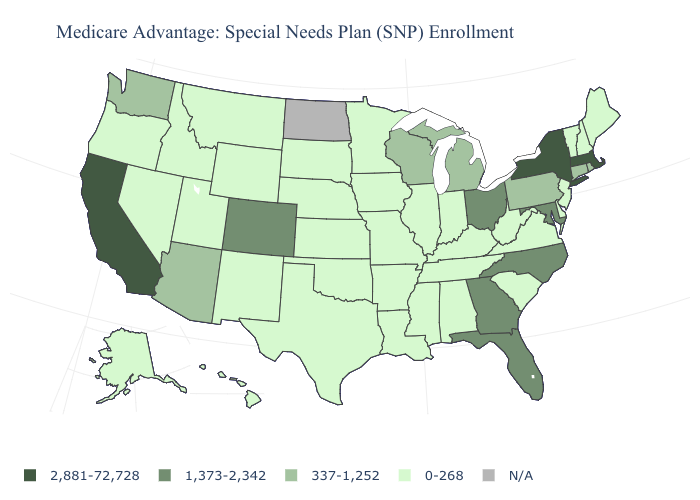What is the value of Arizona?
Concise answer only. 337-1,252. Is the legend a continuous bar?
Give a very brief answer. No. What is the lowest value in states that border North Dakota?
Write a very short answer. 0-268. Name the states that have a value in the range 0-268?
Short answer required. Alaska, Alabama, Arkansas, Delaware, Hawaii, Iowa, Idaho, Illinois, Indiana, Kansas, Kentucky, Louisiana, Maine, Minnesota, Missouri, Mississippi, Montana, Nebraska, New Hampshire, New Jersey, New Mexico, Nevada, Oklahoma, Oregon, South Carolina, South Dakota, Tennessee, Texas, Utah, Virginia, Vermont, West Virginia, Wyoming. What is the value of New York?
Short answer required. 2,881-72,728. What is the value of Kansas?
Concise answer only. 0-268. Name the states that have a value in the range N/A?
Keep it brief. North Dakota. What is the lowest value in the MidWest?
Answer briefly. 0-268. What is the value of Montana?
Short answer required. 0-268. What is the lowest value in the USA?
Write a very short answer. 0-268. What is the highest value in states that border Montana?
Answer briefly. 0-268. What is the value of Montana?
Answer briefly. 0-268. Name the states that have a value in the range N/A?
Answer briefly. North Dakota. Among the states that border Missouri , which have the highest value?
Concise answer only. Arkansas, Iowa, Illinois, Kansas, Kentucky, Nebraska, Oklahoma, Tennessee. 